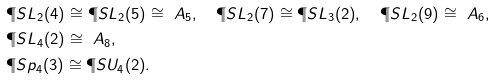Convert formula to latex. <formula><loc_0><loc_0><loc_500><loc_500>& \P S L _ { 2 } ( 4 ) \cong \P S L _ { 2 } ( 5 ) \cong \ A _ { 5 } , \quad \P S L _ { 2 } ( 7 ) \cong \P S L _ { 3 } ( 2 ) , \quad \P S L _ { 2 } ( 9 ) \cong \ A _ { 6 } , \\ & \P S L _ { 4 } ( 2 ) \cong \ A _ { 8 } , \\ & \P S p _ { 4 } ( 3 ) \cong \P S U _ { 4 } ( 2 ) .</formula> 